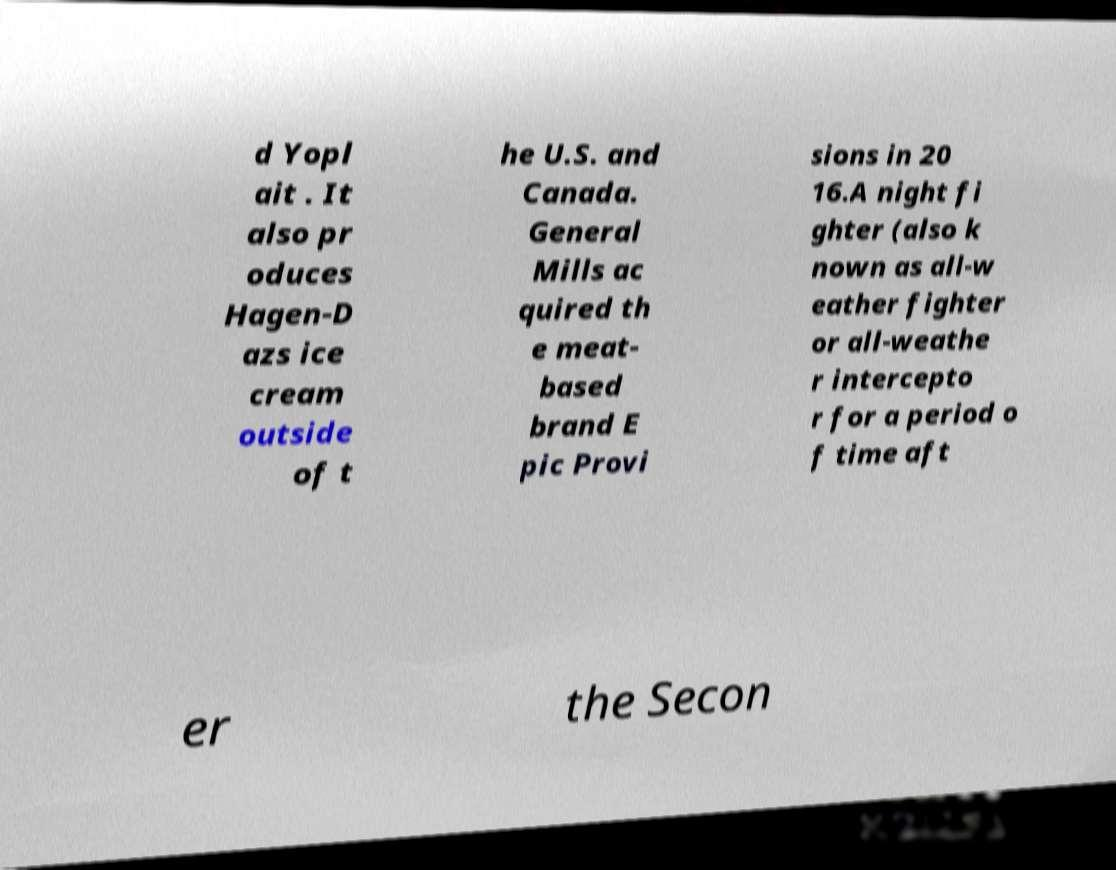What messages or text are displayed in this image? I need them in a readable, typed format. d Yopl ait . It also pr oduces Hagen-D azs ice cream outside of t he U.S. and Canada. General Mills ac quired th e meat- based brand E pic Provi sions in 20 16.A night fi ghter (also k nown as all-w eather fighter or all-weathe r intercepto r for a period o f time aft er the Secon 